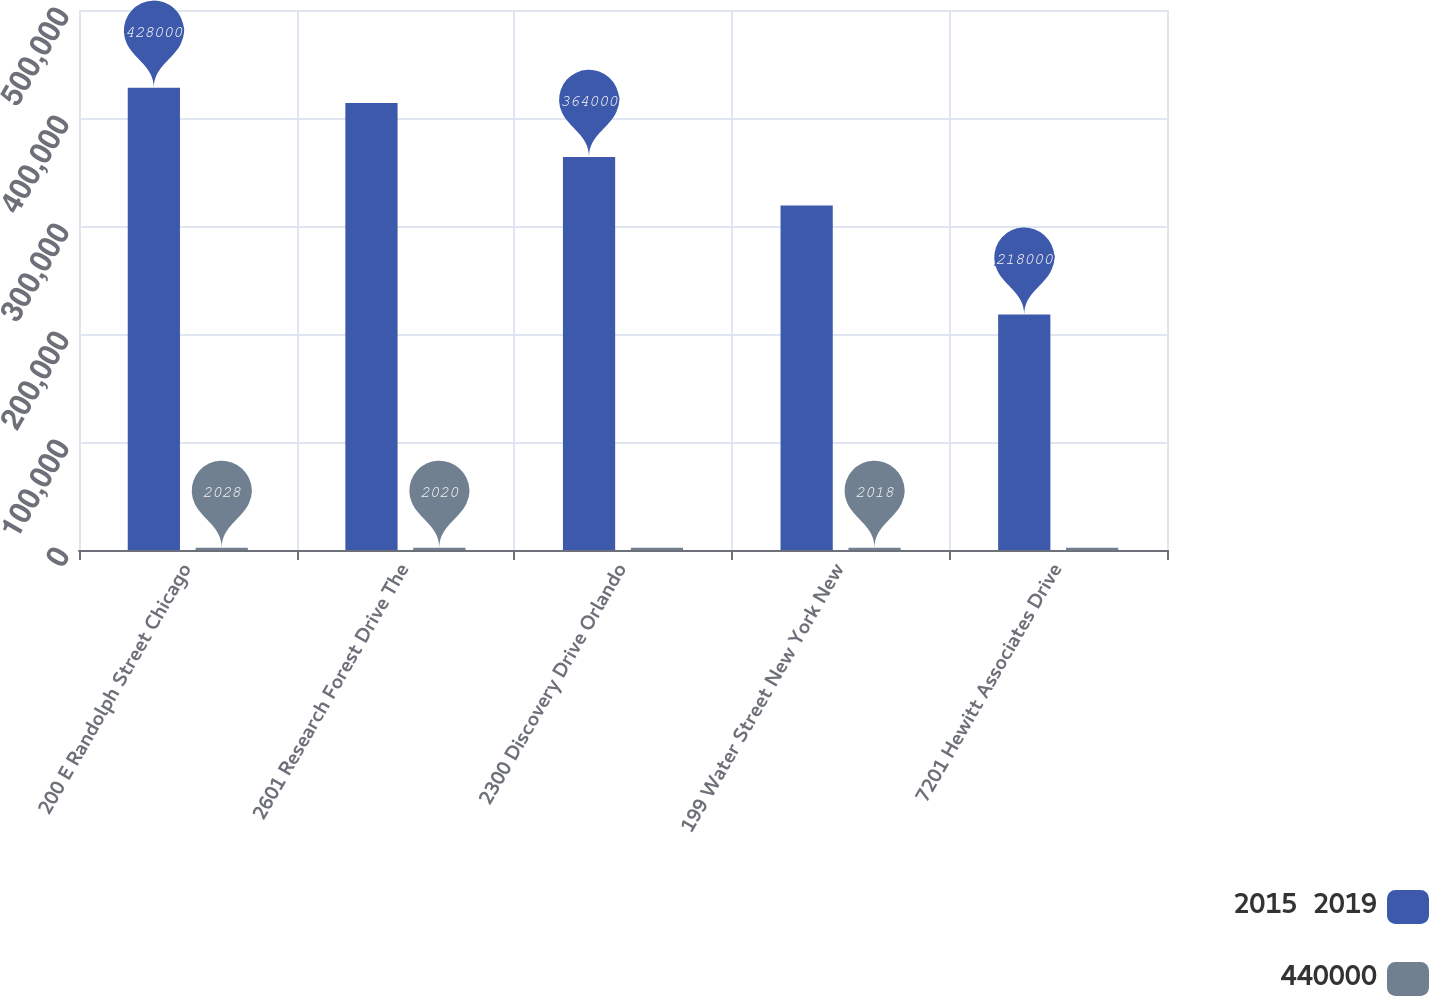Convert chart to OTSL. <chart><loc_0><loc_0><loc_500><loc_500><stacked_bar_chart><ecel><fcel>200 E Randolph Street Chicago<fcel>2601 Research Forest Drive The<fcel>2300 Discovery Drive Orlando<fcel>199 Water Street New York New<fcel>7201 Hewitt Associates Drive<nl><fcel>2015  2019<fcel>428000<fcel>414000<fcel>364000<fcel>319000<fcel>218000<nl><fcel>440000<fcel>2028<fcel>2020<fcel>2020<fcel>2018<fcel>2025<nl></chart> 